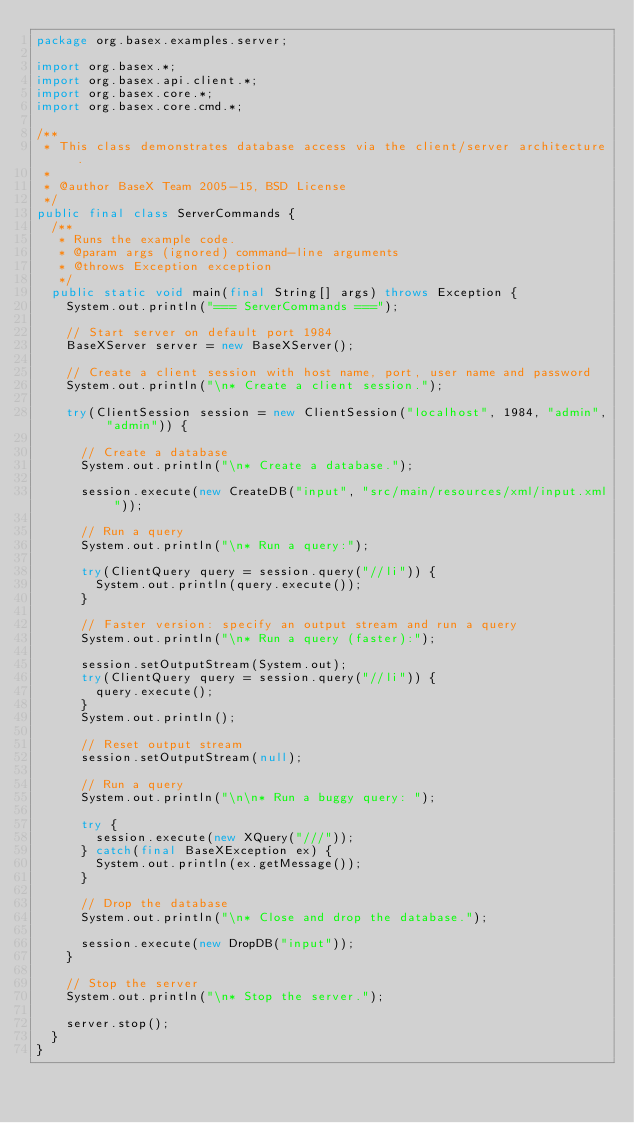<code> <loc_0><loc_0><loc_500><loc_500><_Java_>package org.basex.examples.server;

import org.basex.*;
import org.basex.api.client.*;
import org.basex.core.*;
import org.basex.core.cmd.*;

/**
 * This class demonstrates database access via the client/server architecture.
 *
 * @author BaseX Team 2005-15, BSD License
 */
public final class ServerCommands {
  /**
   * Runs the example code.
   * @param args (ignored) command-line arguments
   * @throws Exception exception
   */
  public static void main(final String[] args) throws Exception {
    System.out.println("=== ServerCommands ===");

    // Start server on default port 1984
    BaseXServer server = new BaseXServer();

    // Create a client session with host name, port, user name and password
    System.out.println("\n* Create a client session.");

    try(ClientSession session = new ClientSession("localhost", 1984, "admin", "admin")) {

      // Create a database
      System.out.println("\n* Create a database.");

      session.execute(new CreateDB("input", "src/main/resources/xml/input.xml"));

      // Run a query
      System.out.println("\n* Run a query:");

      try(ClientQuery query = session.query("//li")) {
        System.out.println(query.execute());
      }

      // Faster version: specify an output stream and run a query
      System.out.println("\n* Run a query (faster):");

      session.setOutputStream(System.out);
      try(ClientQuery query = session.query("//li")) {
        query.execute();
      }
      System.out.println();

      // Reset output stream
      session.setOutputStream(null);

      // Run a query
      System.out.println("\n\n* Run a buggy query: ");

      try {
        session.execute(new XQuery("///"));
      } catch(final BaseXException ex) {
        System.out.println(ex.getMessage());
      }

      // Drop the database
      System.out.println("\n* Close and drop the database.");

      session.execute(new DropDB("input"));
    }

    // Stop the server
    System.out.println("\n* Stop the server.");

    server.stop();
  }
}
</code> 